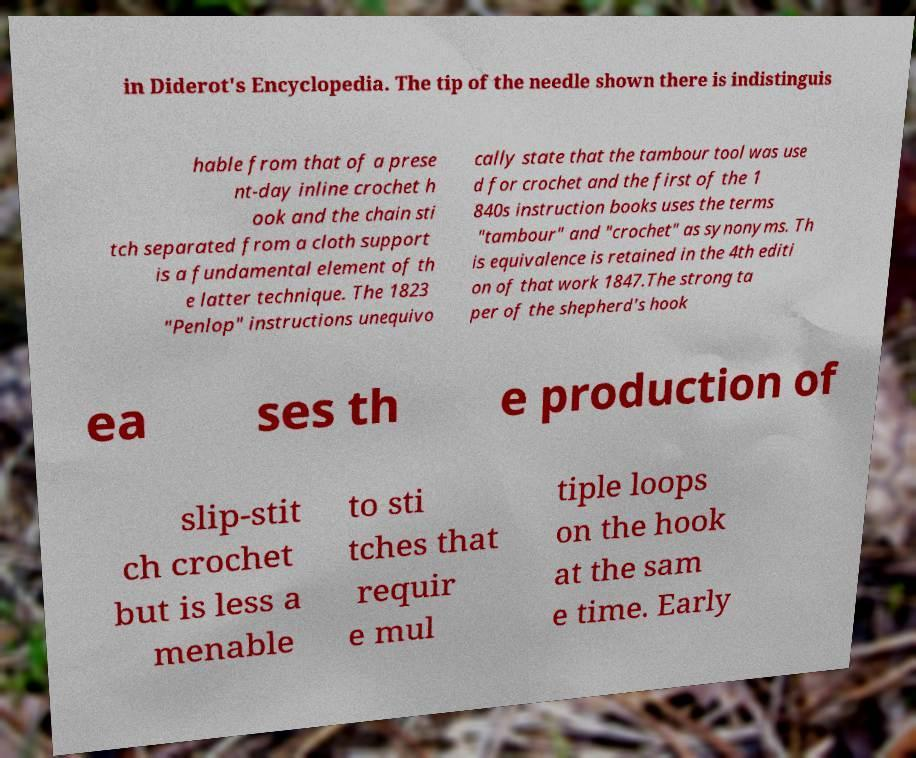For documentation purposes, I need the text within this image transcribed. Could you provide that? in Diderot's Encyclopedia. The tip of the needle shown there is indistinguis hable from that of a prese nt-day inline crochet h ook and the chain sti tch separated from a cloth support is a fundamental element of th e latter technique. The 1823 "Penlop" instructions unequivo cally state that the tambour tool was use d for crochet and the first of the 1 840s instruction books uses the terms "tambour" and "crochet" as synonyms. Th is equivalence is retained in the 4th editi on of that work 1847.The strong ta per of the shepherd's hook ea ses th e production of slip-stit ch crochet but is less a menable to sti tches that requir e mul tiple loops on the hook at the sam e time. Early 